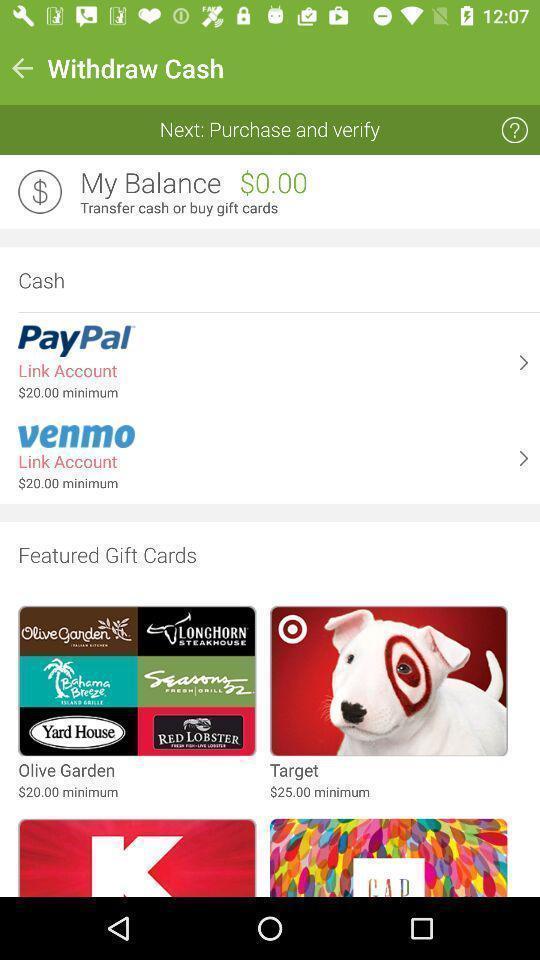Describe the visual elements of this screenshot. Page showing options from a cash app. 